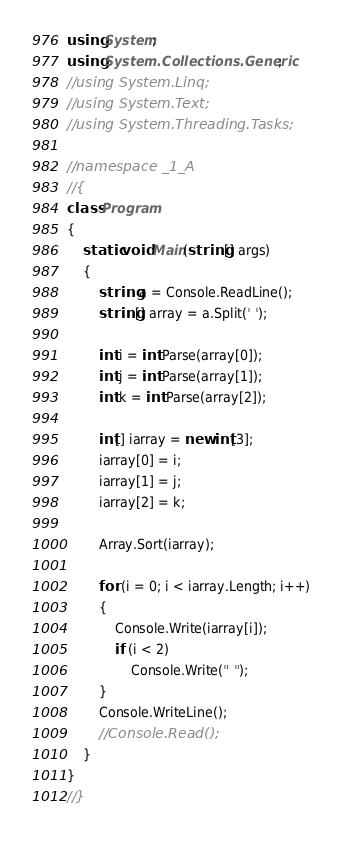Convert code to text. <code><loc_0><loc_0><loc_500><loc_500><_C#_>using System;
using System.Collections.Generic;
//using System.Linq;
//using System.Text;
//using System.Threading.Tasks;

//namespace _1_A
//{
class Program
{
    static void Main(string[] args)
    {
        string a = Console.ReadLine();
        string[] array = a.Split(' ');

        int i = int.Parse(array[0]);
        int j = int.Parse(array[1]);
        int k = int.Parse(array[2]);

        int[] iarray = new int[3];
        iarray[0] = i;
        iarray[1] = j;
        iarray[2] = k;

        Array.Sort(iarray);

        for (i = 0; i < iarray.Length; i++)
        {
            Console.Write(iarray[i]);
            if (i < 2)
                Console.Write(" ");
        }
        Console.WriteLine();
        //Console.Read();
    }
}
//}</code> 